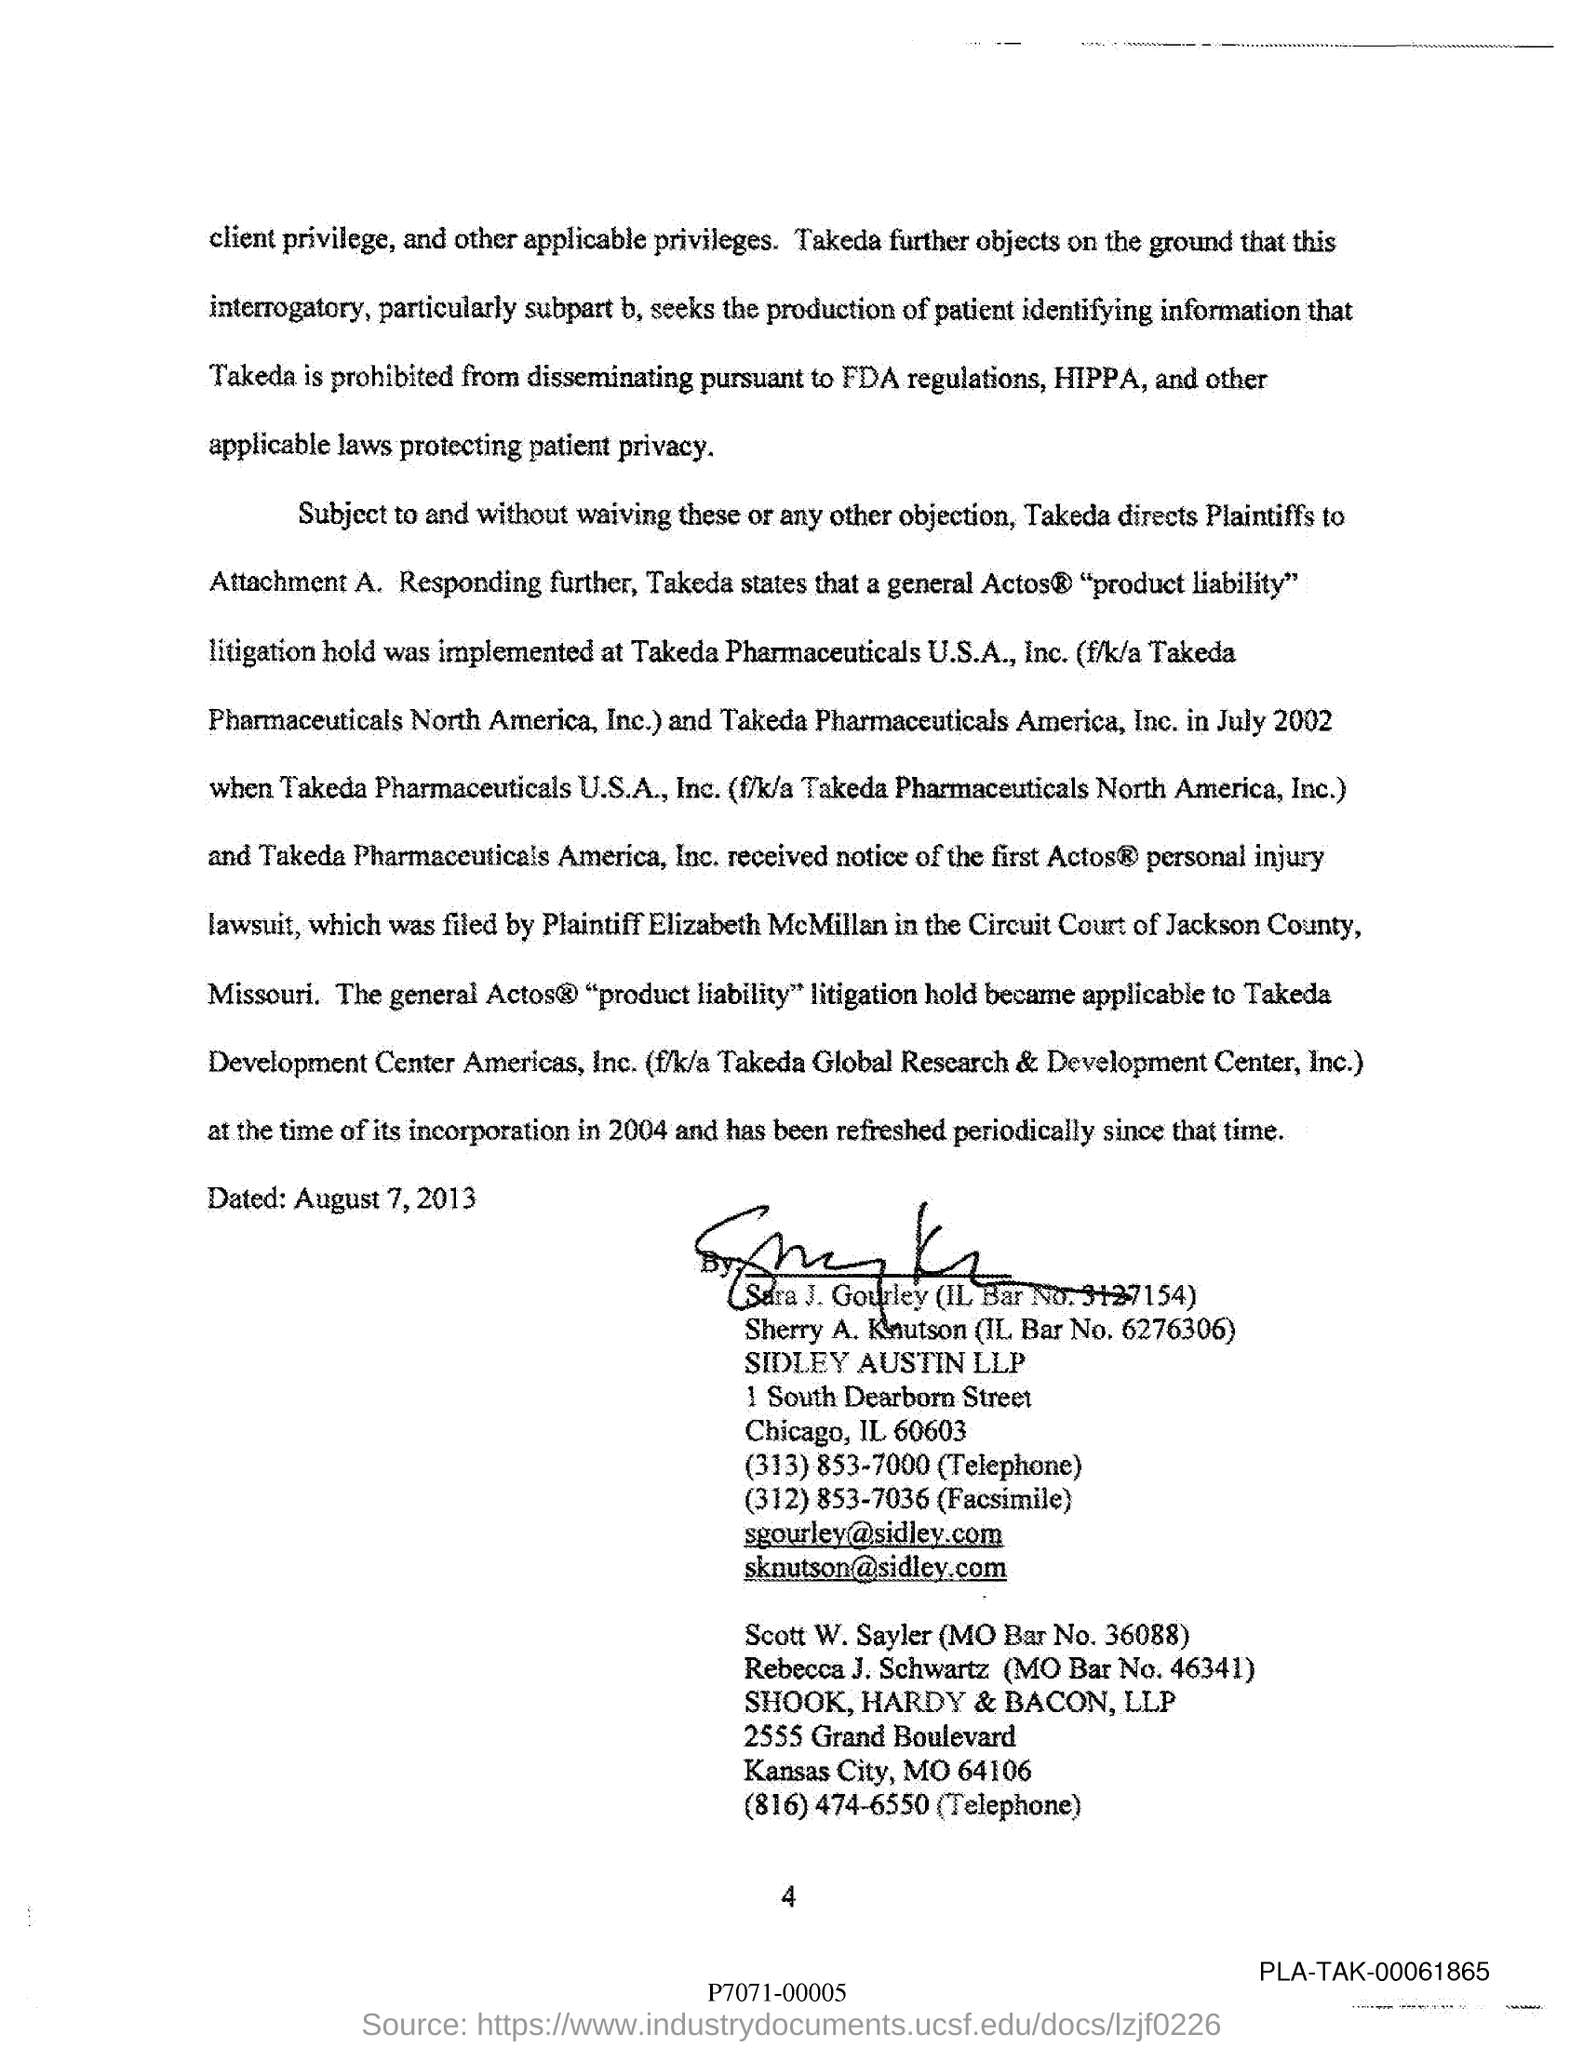What can you tell about the law firm mentioned in the document? The document lists a law firm named SIDLEY AUSTIN LLP located in Chicago. It also lists another firm, SHOOK, HARDY & BACON, LLP, located in Kansas City. These firms may represent different parties involved in the legal proceedings outlined in the document. 